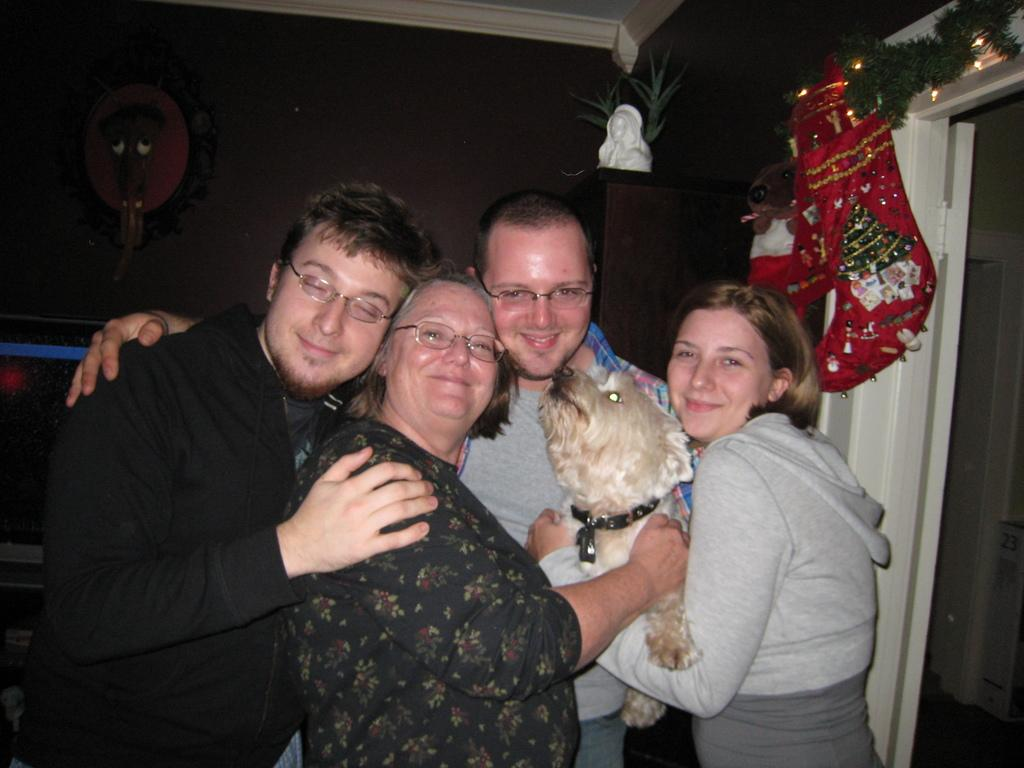How many people are in the image? There are four persons standing in the center of the image. What are the people doing in the image? The persons are smiling and holding a dog. What can be seen in the background of the image? There is a wall and objects present in the background of the image. What type of scissors is the dog using to cut the boot in the image? There is no dog using scissors or any boot present in the image. 